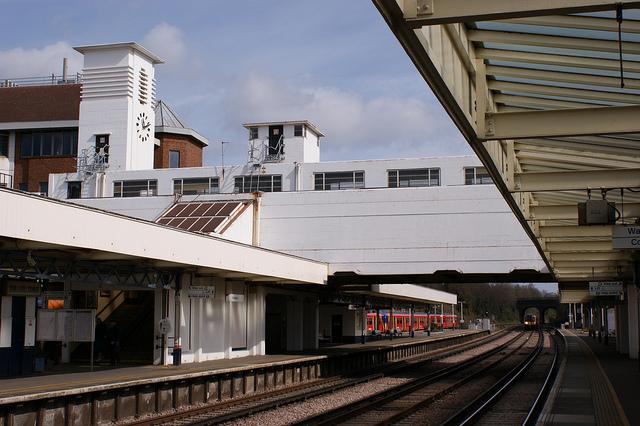What is this building?
Short answer required. Train station. Are there clouds in the sky?
Give a very brief answer. Yes. Is the train coming or going?
Answer briefly. Coming. Is it sunny?
Answer briefly. Yes. What time is it?
Write a very short answer. 11:12. What is on the tracks?
Keep it brief. Train. 